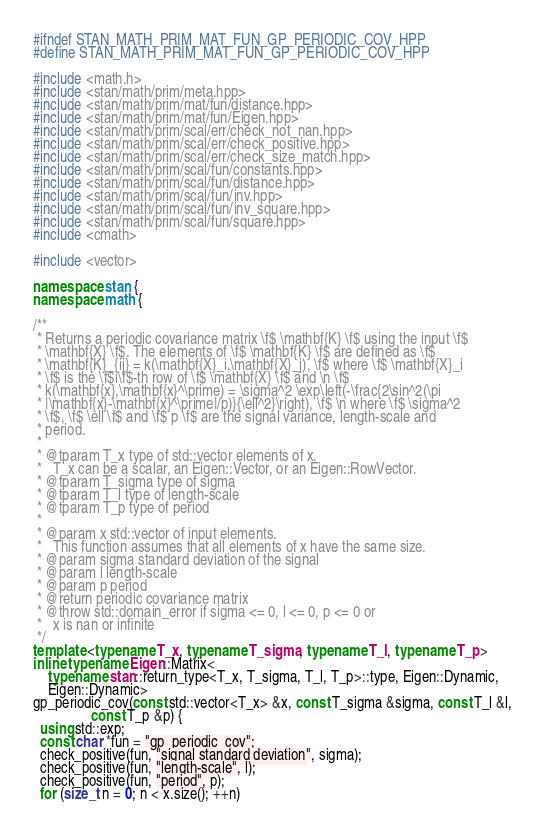<code> <loc_0><loc_0><loc_500><loc_500><_C++_>#ifndef STAN_MATH_PRIM_MAT_FUN_GP_PERIODIC_COV_HPP
#define STAN_MATH_PRIM_MAT_FUN_GP_PERIODIC_COV_HPP

#include <math.h>
#include <stan/math/prim/meta.hpp>
#include <stan/math/prim/mat/fun/distance.hpp>
#include <stan/math/prim/mat/fun/Eigen.hpp>
#include <stan/math/prim/scal/err/check_not_nan.hpp>
#include <stan/math/prim/scal/err/check_positive.hpp>
#include <stan/math/prim/scal/err/check_size_match.hpp>
#include <stan/math/prim/scal/fun/constants.hpp>
#include <stan/math/prim/scal/fun/distance.hpp>
#include <stan/math/prim/scal/fun/inv.hpp>
#include <stan/math/prim/scal/fun/inv_square.hpp>
#include <stan/math/prim/scal/fun/square.hpp>
#include <cmath>

#include <vector>

namespace stan {
namespace math {

/**
 * Returns a periodic covariance matrix \f$ \mathbf{K} \f$ using the input \f$
 * \mathbf{X} \f$. The elements of \f$ \mathbf{K} \f$ are defined as \f$
 * \mathbf{K}_{ij} = k(\mathbf{X}_i,\mathbf{X}_j), \f$ where \f$ \mathbf{X}_i
 * \f$ is the \f$i\f$-th row of \f$ \mathbf{X} \f$ and \n \f$
 * k(\mathbf{x},\mathbf{x}^\prime) = \sigma^2 \exp\left(-\frac{2\sin^2(\pi
 * |\mathbf{x}-\mathbf{x}^\prime|/p)}{\ell^2}\right), \f$ \n where \f$ \sigma^2
 * \f$, \f$ \ell \f$ and \f$ p \f$ are the signal variance, length-scale and
 * period.
 *
 * @tparam T_x type of std::vector elements of x.
 *   T_x can be a scalar, an Eigen::Vector, or an Eigen::RowVector.
 * @tparam T_sigma type of sigma
 * @tparam T_l type of length-scale
 * @tparam T_p type of period
 *
 * @param x std::vector of input elements.
 *   This function assumes that all elements of x have the same size.
 * @param sigma standard deviation of the signal
 * @param l length-scale
 * @param p period
 * @return periodic covariance matrix
 * @throw std::domain_error if sigma <= 0, l <= 0, p <= 0 or
 *   x is nan or infinite
 */
template <typename T_x, typename T_sigma, typename T_l, typename T_p>
inline typename Eigen::Matrix<
    typename stan::return_type<T_x, T_sigma, T_l, T_p>::type, Eigen::Dynamic,
    Eigen::Dynamic>
gp_periodic_cov(const std::vector<T_x> &x, const T_sigma &sigma, const T_l &l,
                const T_p &p) {
  using std::exp;
  const char *fun = "gp_periodic_cov";
  check_positive(fun, "signal standard deviation", sigma);
  check_positive(fun, "length-scale", l);
  check_positive(fun, "period", p);
  for (size_t n = 0; n < x.size(); ++n)</code> 